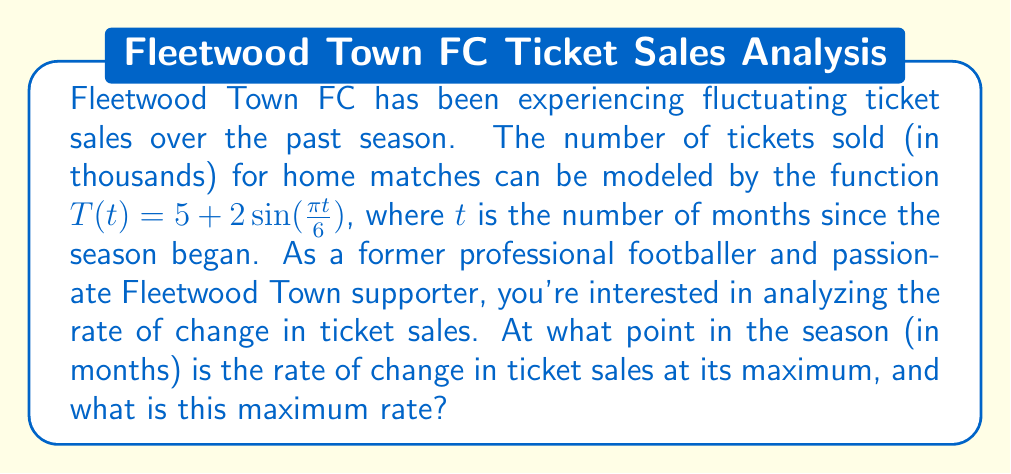Help me with this question. To solve this problem, we need to follow these steps:

1) First, we need to find the rate of change of ticket sales, which is given by the derivative of $T(t)$:

   $$T'(t) = \frac{d}{dt}[5 + 2\sin(\frac{\pi t}{6})] = 2 \cdot \frac{\pi}{6} \cos(\frac{\pi t}{6}) = \frac{\pi}{3} \cos(\frac{\pi t}{6})$$

2) To find the maximum rate of change, we need to find the maximum value of $T'(t)$. The cosine function has a maximum value of 1, which occurs when its argument is 0 (or any multiple of $2\pi$).

3) So, we need to solve:

   $$\frac{\pi t}{6} = 0, 2\pi, 4\pi, ...$$

4) The smallest positive solution is when $t = 0$, which corresponds to the beginning of the season. The next solution would be when $t = 12$, which is the end of the season (assuming a 12-month season).

5) The maximum rate of change occurs at these points, and its value is:

   $$T'(0) = \frac{\pi}{3} \cos(0) = \frac{\pi}{3} \approx 1.047$$

This means the maximum rate of change is approximately 1,047 tickets per month.
Answer: The rate of change in ticket sales is at its maximum at the beginning of the season ($t = 0$ months) and at the end of the season ($t = 12$ months). The maximum rate of change is $\frac{\pi}{3}$ thousand tickets per month, or approximately 1,047 tickets per month. 